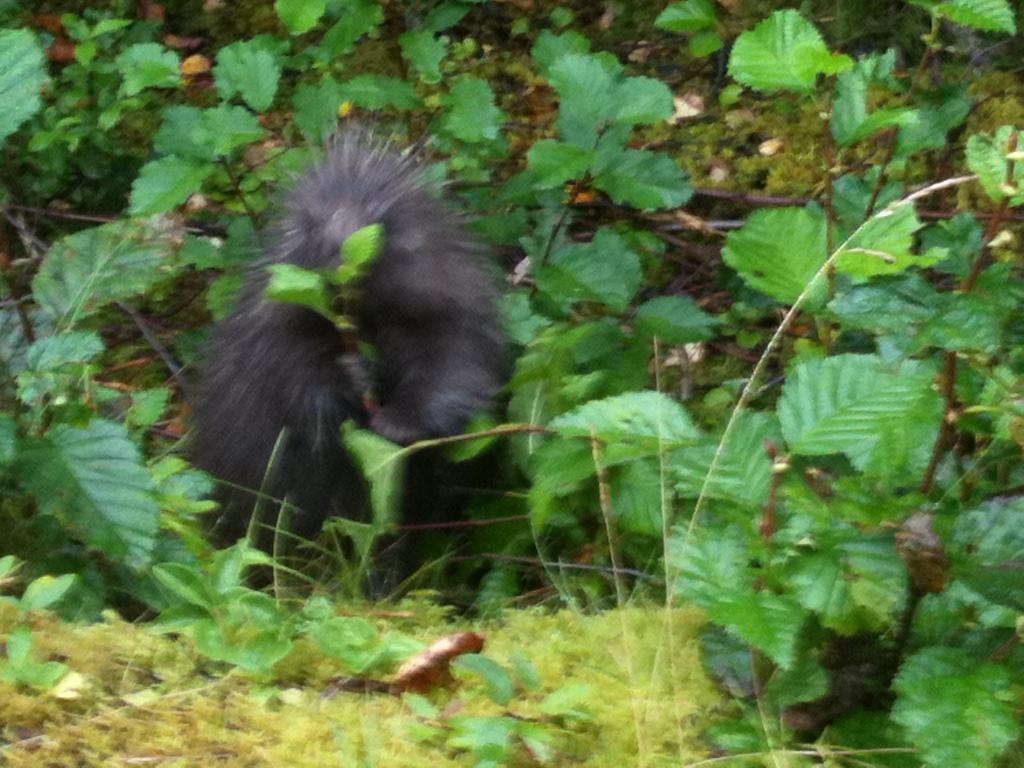Please provide a concise description of this image. In this image in the center there is one animal and there are some leaves and grass. 